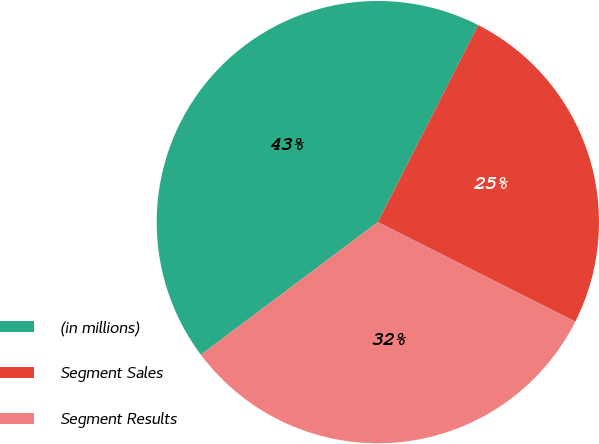Convert chart. <chart><loc_0><loc_0><loc_500><loc_500><pie_chart><fcel>(in millions)<fcel>Segment Sales<fcel>Segment Results<nl><fcel>42.74%<fcel>24.93%<fcel>32.34%<nl></chart> 